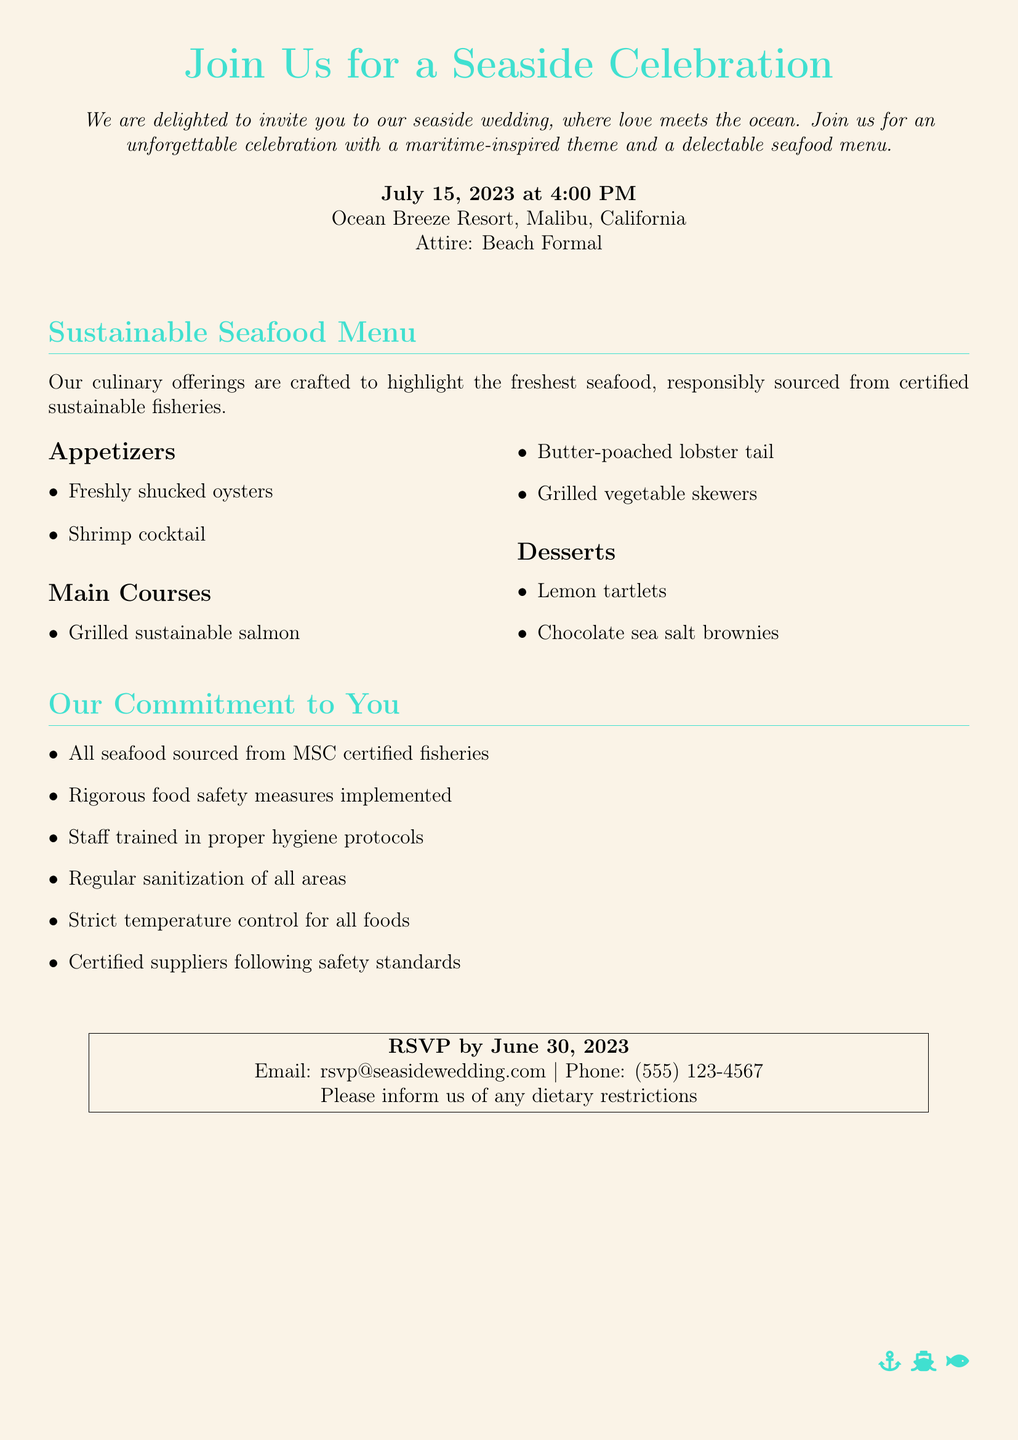What is the date of the wedding? The date of the wedding is explicitly mentioned in the document as July 15, 2023.
Answer: July 15, 2023 What is the location of the wedding? The document lists Ocean Breeze Resort, Malibu, California as the venue for the wedding.
Answer: Ocean Breeze Resort, Malibu, California What time does the wedding start? The document states that the wedding will start at 4:00 PM.
Answer: 4:00 PM What type of menu is being offered? The document refers to a "Sustainable Seafood Menu," indicating the type of cuisine at the event.
Answer: Sustainable Seafood Menu How long before the wedding should guests RSVP? The RSVP deadline is given as June 30, 2023, which is before the wedding date.
Answer: June 30, 2023 What are the appetizers listed in the menu? The appetizers mentioned are Freshly shucked oysters and Shrimp cocktail.
Answer: Freshly shucked oysters, Shrimp cocktail What commitment is made to food safety? The document lists "Rigorous food safety measures implemented" as part of the commitment to guests.
Answer: Rigorous food safety measures implemented What protocol is staff trained in? The document highlights that staff are trained in "proper hygiene protocols."
Answer: proper hygiene protocols What attire is suggested for the wedding? The document specifies the attire as "Beach Formal."
Answer: Beach Formal 